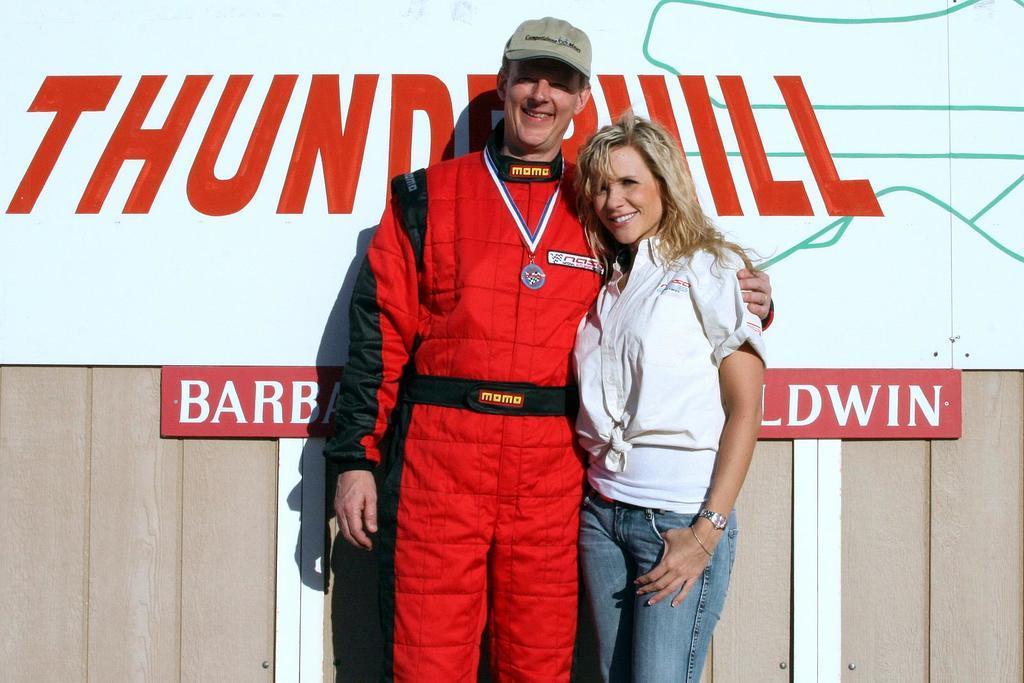Please provide a concise description of this image. In this image in the center there is one man and one women who are standing and smiling and in the background there is a wooden wall. On the wall there are some boards, on the boards there is some text. 